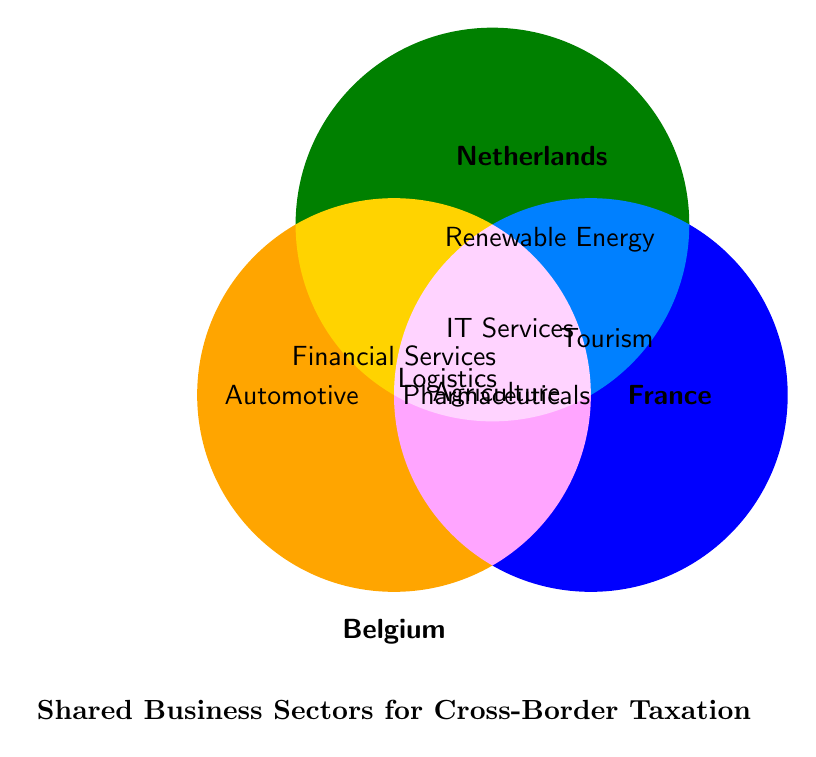How many sectors are shared by Belgium, Netherlands, and France? Look at the intersection point where all three circles overlap. Identify the sectors located within this intersected area.
Answer: Three Which sectors are exclusive to Belgium and Netherlands but not France? Examine the intersection between the Belgium and Netherlands circles, excluding France. Look for sectors within this area.
Answer: IT Services What's the total number of sectors shared exclusively between Belgium and France? Identify the sectors in the overlapping area between Belgium and France but not overlapping with the Netherlands. Count those sectors.
Answer: Three Which countries share the Renewable Energy sector? Find the sector label "Renewable Energy" and identify which circles (countries) overlap with this label.
Answer: Netherlands and France How many sectors does Belgium share with other countries? Sum the sectors that overlap with Belgium and any other country (Netherlands or France). Count this carefully.
Answer: Five Compare the number of sectors shared between Belgium-France and Netherlands-France. Which is greater? Identify the sectors in the overlap areas of Belgium-France and Netherlands-France. Compare the counts.
Answer: Equal Which sector does Belgium have that neither Netherlands nor France has? Locate sectors that fall within only the Belgium area without overlapping with any other circles.
Answer: None Does the Agriculture sector include Belgium? Check the placement of the Agriculture label and see if it overlaps with the Belgium circle.
Answer: Yes Identify the sectors exclusive to the Netherlands and France but not Belgium. Look at the intersection between Netherlands and France, ensuring these areas do not overlap with Belgium.
Answer: Renewable Energy and Tourism What is the overall number of unique sectors discussed? Count each unique sector label present in any of the circles, regardless of overlap.
Answer: Eight 